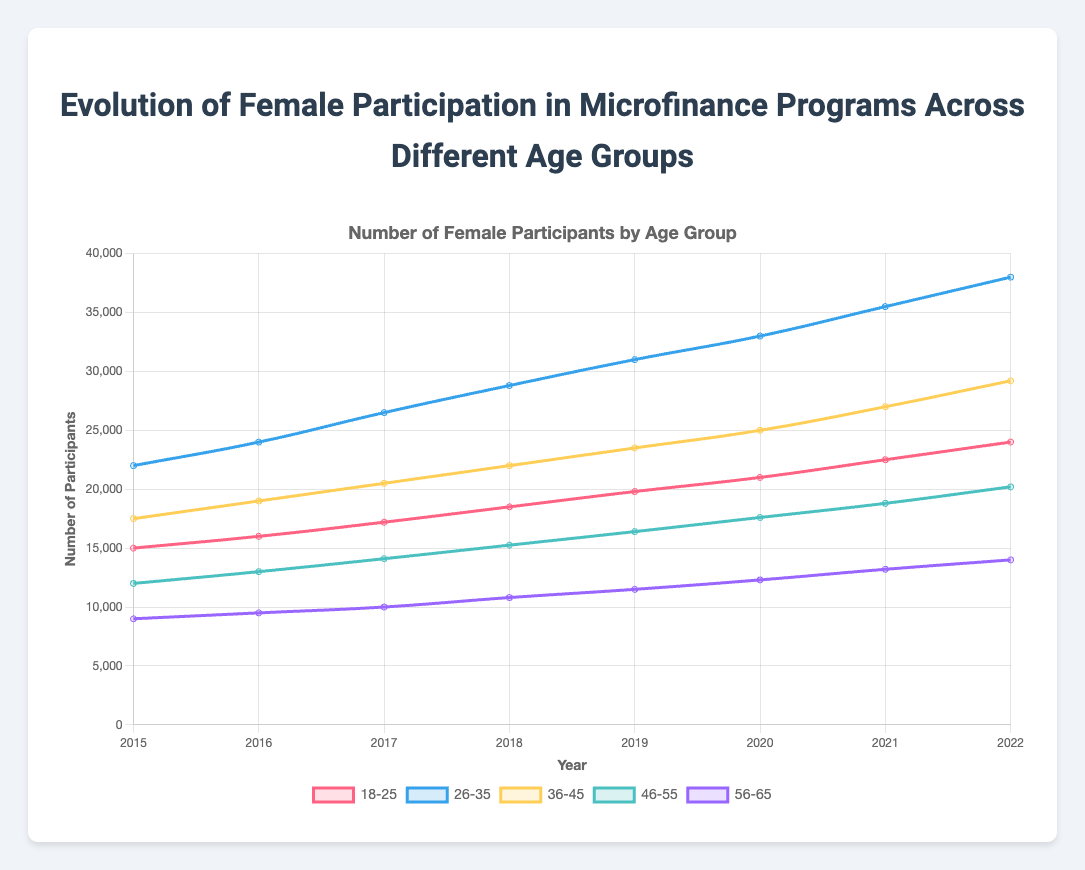Which age group had the highest female participation in microfinance programs in 2022? In 2022, the "26-35" age group had the highest number of participants, as indicated by the highest point on the line graph for that year
Answer: 26-35 How did the participation in the "18-25" age group change from 2015 to 2022? In 2015, the participation was 15,000, and it increased to 24,000 by 2022, showing a growth of 9,000 participants
Answer: Increased by 9,000 Which age group saw the greatest absolute increase in participation from 2015 to 2022? The "26-35" age group increased from 22,000 in 2015 to 38,000 in 2022, resulting in an absolute increase of 16,000, the largest among all age groups
Answer: 26-35 Compare the participation trends for the "46-55" and "56-65" age groups between 2015 and 2022. Which group had a steeper increase? The "46-55" group increased from 12,000 in 2015 to 20,200 in 2022 (an increase of 8,200), while the "56-65" group went from 9,000 to 14,000 in the same period (an increase of 5,000). Thus, the "46-55" group had a steeper increase
Answer: 46-55 Which age groups had a consistent increase in participation year over year from 2015 to 2022? By observing the lines on the graph, it is clear that all age groups (18-25, 26-35, 36-45, 46-55, 56-65) show a consistent year-over-year increase in participation
Answer: All age groups What was the average number of participants in the "36-45" age group from 2015 to 2022? Sum the participants from 2015 to 2022 for the "36-45" group: (17,500 + 19,000 + 20,500 + 22,000 + 23,500 + 25,000 + 27,000 + 29,200) = 183,700. Then, divide by the number of years (8): 183,700 / 8 = 22,962.5
Answer: 22,962.5 How did the participation rates in the "26-35" and "36-45" age groups compare in 2020? In 2020, the "26-35" group had 33,000 participants, while the "36-45" group had 25,000 participants. Thus, the "26-35" group had more participants
Answer: 26-35 had more What is the total number of participants recorded in the year 2019 across all age groups? Sum the participants for all age groups in 2019: (19,800 + 31,000 + 23,500 + 16,400 + 11,500) = 102,200
Answer: 102,200 Which age group experienced the smallest absolute increase in participants from 2015 to 2022? The "56-65" age group saw an increase from 9,000 in 2015 to 14,000 in 2022, an increase of 5,000, which is the smallest compared to other age groups
Answer: 56-65 